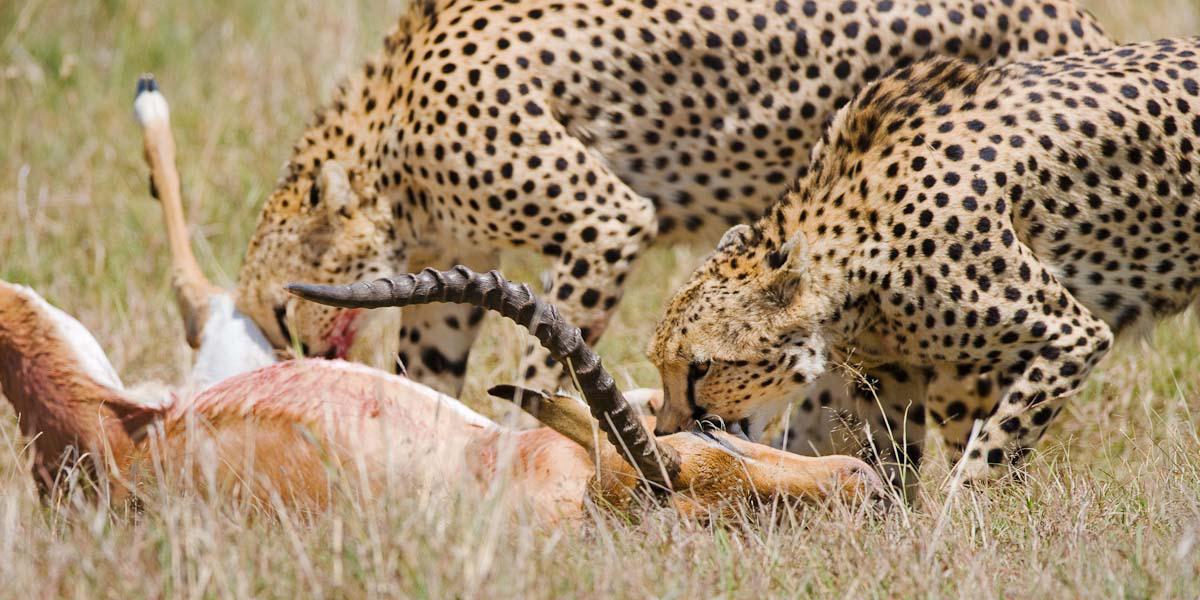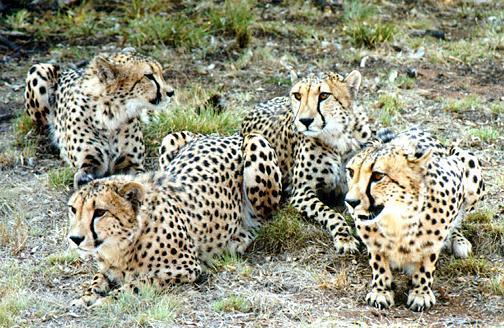The first image is the image on the left, the second image is the image on the right. Assess this claim about the two images: "There are no more than three animals in one of the images.". Correct or not? Answer yes or no. No. 